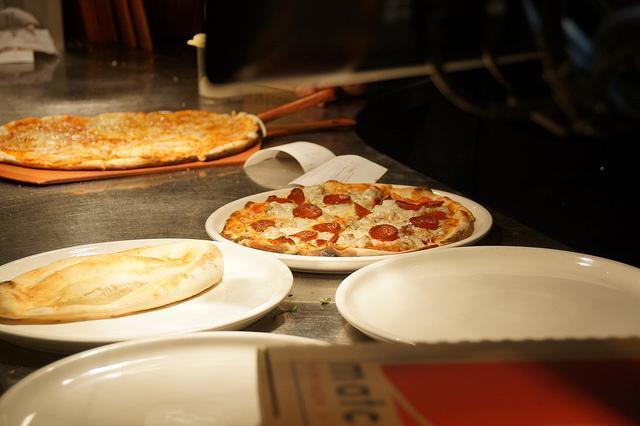How many plates can you see?
Give a very brief answer. 4. How many pizzas are there?
Give a very brief answer. 2. How many pizzas can you see?
Give a very brief answer. 3. 